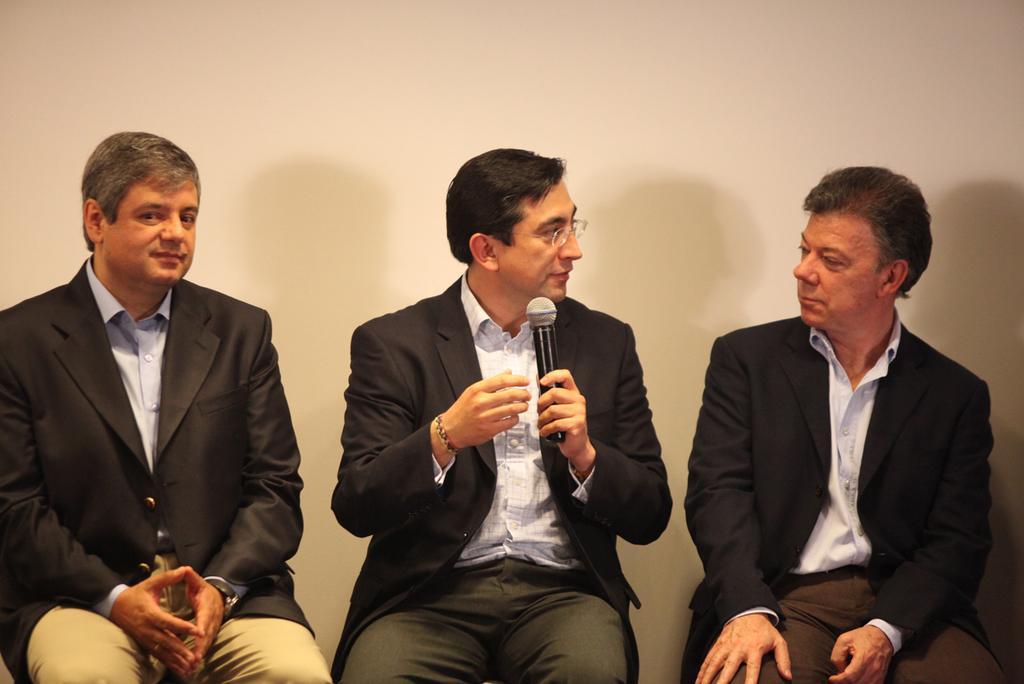How would you summarize this image in a sentence or two? In this image there are three men sitting. The man in the center is holding a microphone. Behind them there is a wall. 